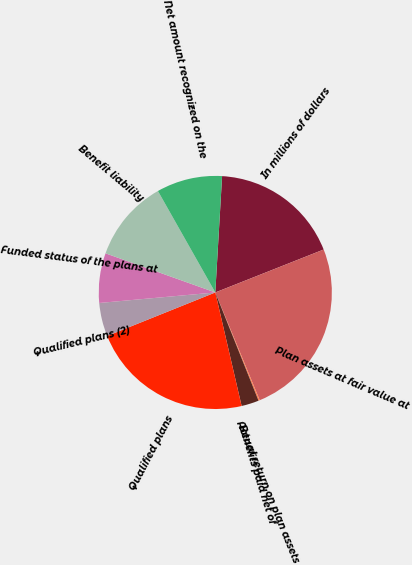Convert chart. <chart><loc_0><loc_0><loc_500><loc_500><pie_chart><fcel>In millions of dollars<fcel>Plan assets at fair value at<fcel>Actual return on plan assets<fcel>Benefits paid net of<fcel>Qualified plans<fcel>Qualified plans (2)<fcel>Funded status of the plans at<fcel>Benefit liability<fcel>Net amount recognized on the<nl><fcel>18.07%<fcel>24.78%<fcel>0.18%<fcel>2.42%<fcel>22.54%<fcel>4.65%<fcel>6.89%<fcel>11.36%<fcel>9.12%<nl></chart> 